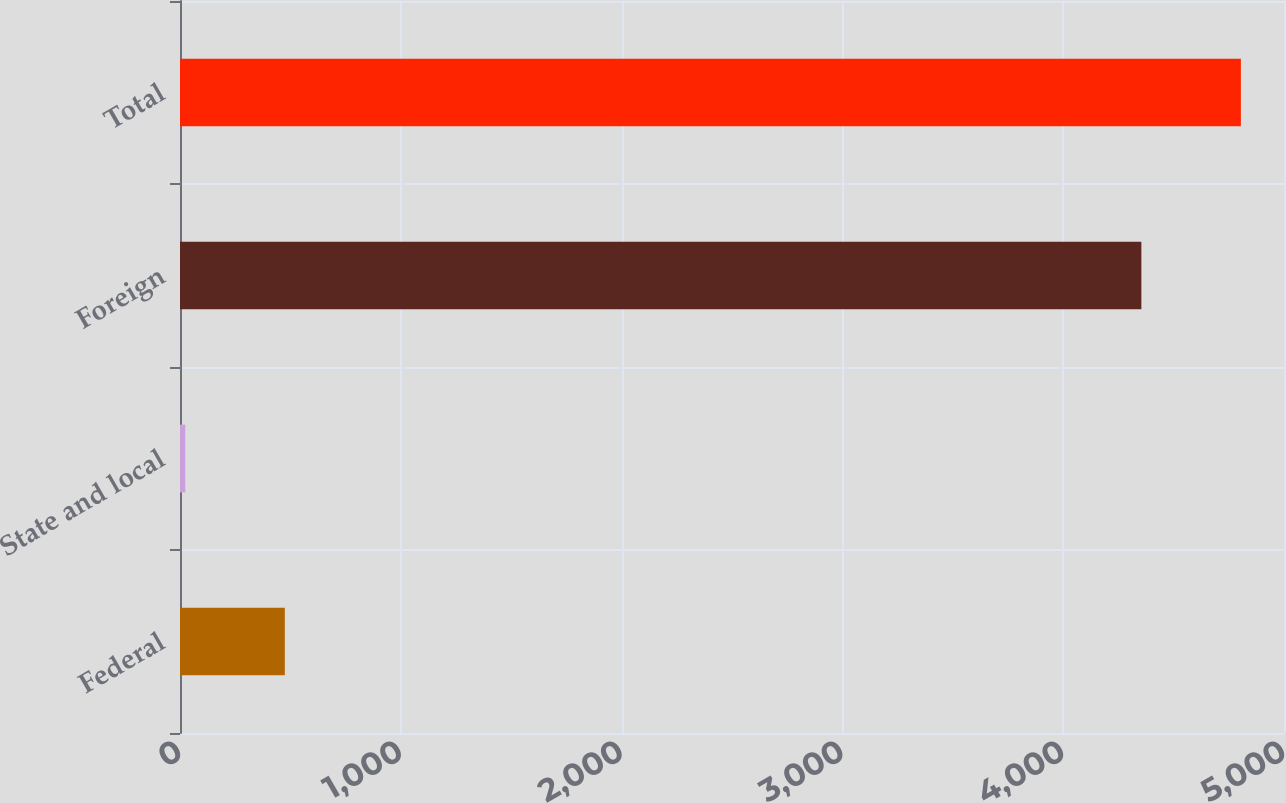Convert chart to OTSL. <chart><loc_0><loc_0><loc_500><loc_500><bar_chart><fcel>Federal<fcel>State and local<fcel>Foreign<fcel>Total<nl><fcel>474.7<fcel>24<fcel>4354<fcel>4804.7<nl></chart> 